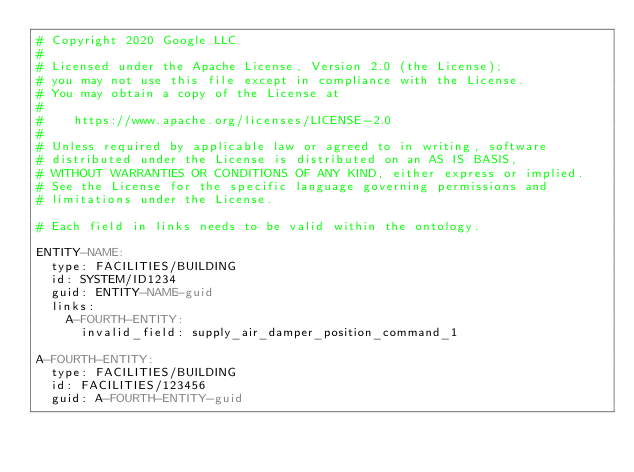Convert code to text. <code><loc_0><loc_0><loc_500><loc_500><_YAML_># Copyright 2020 Google LLC
#
# Licensed under the Apache License, Version 2.0 (the License);
# you may not use this file except in compliance with the License.
# You may obtain a copy of the License at
#
#    https://www.apache.org/licenses/LICENSE-2.0
#
# Unless required by applicable law or agreed to in writing, software
# distributed under the License is distributed on an AS IS BASIS,
# WITHOUT WARRANTIES OR CONDITIONS OF ANY KIND, either express or implied.
# See the License for the specific language governing permissions and
# limitations under the License.

# Each field in links needs to be valid within the ontology.

ENTITY-NAME:
  type: FACILITIES/BUILDING
  id: SYSTEM/ID1234
  guid: ENTITY-NAME-guid
  links:
    A-FOURTH-ENTITY:
      invalid_field: supply_air_damper_position_command_1

A-FOURTH-ENTITY:
  type: FACILITIES/BUILDING
  id: FACILITIES/123456
  guid: A-FOURTH-ENTITY-guid
</code> 